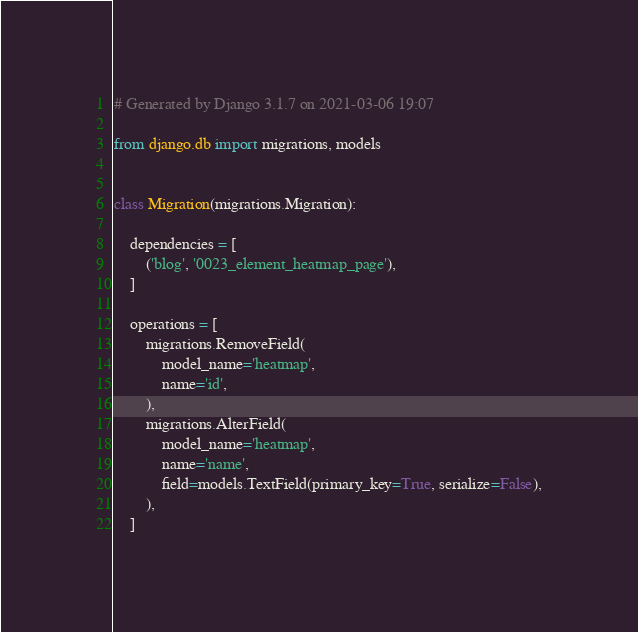<code> <loc_0><loc_0><loc_500><loc_500><_Python_># Generated by Django 3.1.7 on 2021-03-06 19:07

from django.db import migrations, models


class Migration(migrations.Migration):

    dependencies = [
        ('blog', '0023_element_heatmap_page'),
    ]

    operations = [
        migrations.RemoveField(
            model_name='heatmap',
            name='id',
        ),
        migrations.AlterField(
            model_name='heatmap',
            name='name',
            field=models.TextField(primary_key=True, serialize=False),
        ),
    ]
</code> 